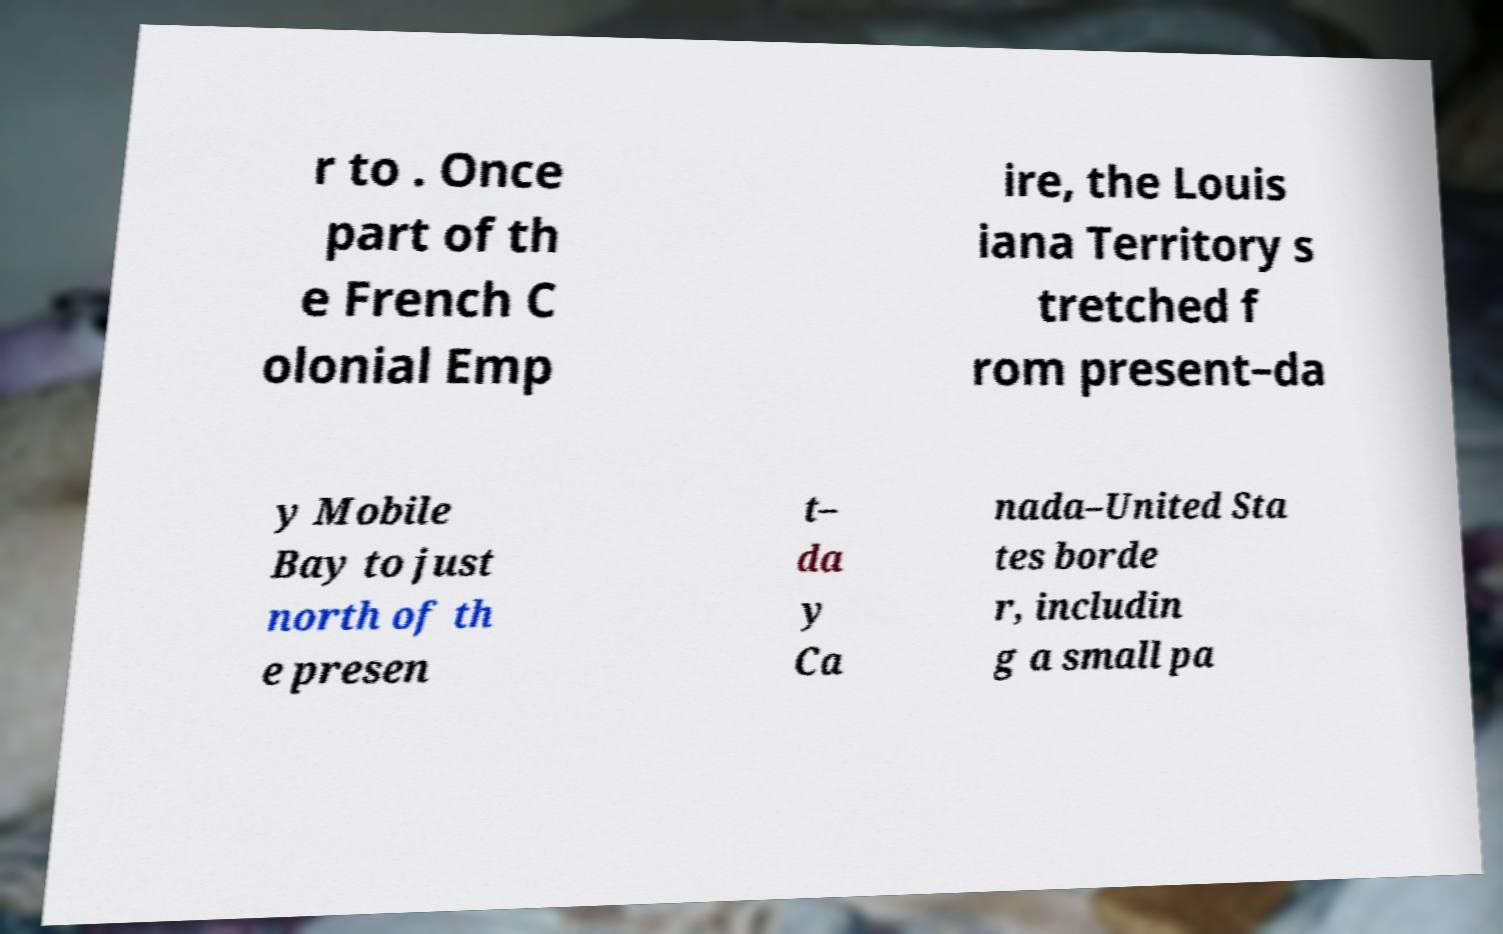I need the written content from this picture converted into text. Can you do that? r to . Once part of th e French C olonial Emp ire, the Louis iana Territory s tretched f rom present–da y Mobile Bay to just north of th e presen t– da y Ca nada–United Sta tes borde r, includin g a small pa 